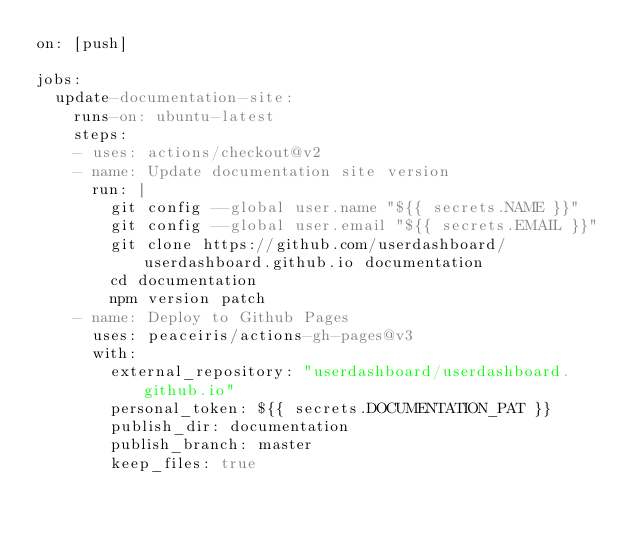<code> <loc_0><loc_0><loc_500><loc_500><_YAML_>on: [push]

jobs:
  update-documentation-site:
    runs-on: ubuntu-latest
    steps:
    - uses: actions/checkout@v2
    - name: Update documentation site version
      run: |
        git config --global user.name "${{ secrets.NAME }}"
        git config --global user.email "${{ secrets.EMAIL }}"
        git clone https://github.com/userdashboard/userdashboard.github.io documentation
        cd documentation
        npm version patch
    - name: Deploy to Github Pages
      uses: peaceiris/actions-gh-pages@v3
      with: 
        external_repository: "userdashboard/userdashboard.github.io"
        personal_token: ${{ secrets.DOCUMENTATION_PAT }}
        publish_dir: documentation
        publish_branch: master
        keep_files: true
</code> 